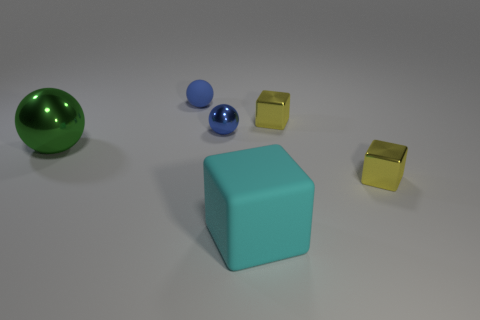Subtract all large blocks. How many blocks are left? 2 Subtract all yellow cubes. How many cubes are left? 1 Subtract all green spheres. How many brown blocks are left? 0 Add 3 cyan cubes. How many cyan cubes exist? 4 Add 4 brown matte cylinders. How many objects exist? 10 Subtract 0 gray spheres. How many objects are left? 6 Subtract all yellow blocks. Subtract all green spheres. How many blocks are left? 1 Subtract all small green metal cylinders. Subtract all blue balls. How many objects are left? 4 Add 1 green objects. How many green objects are left? 2 